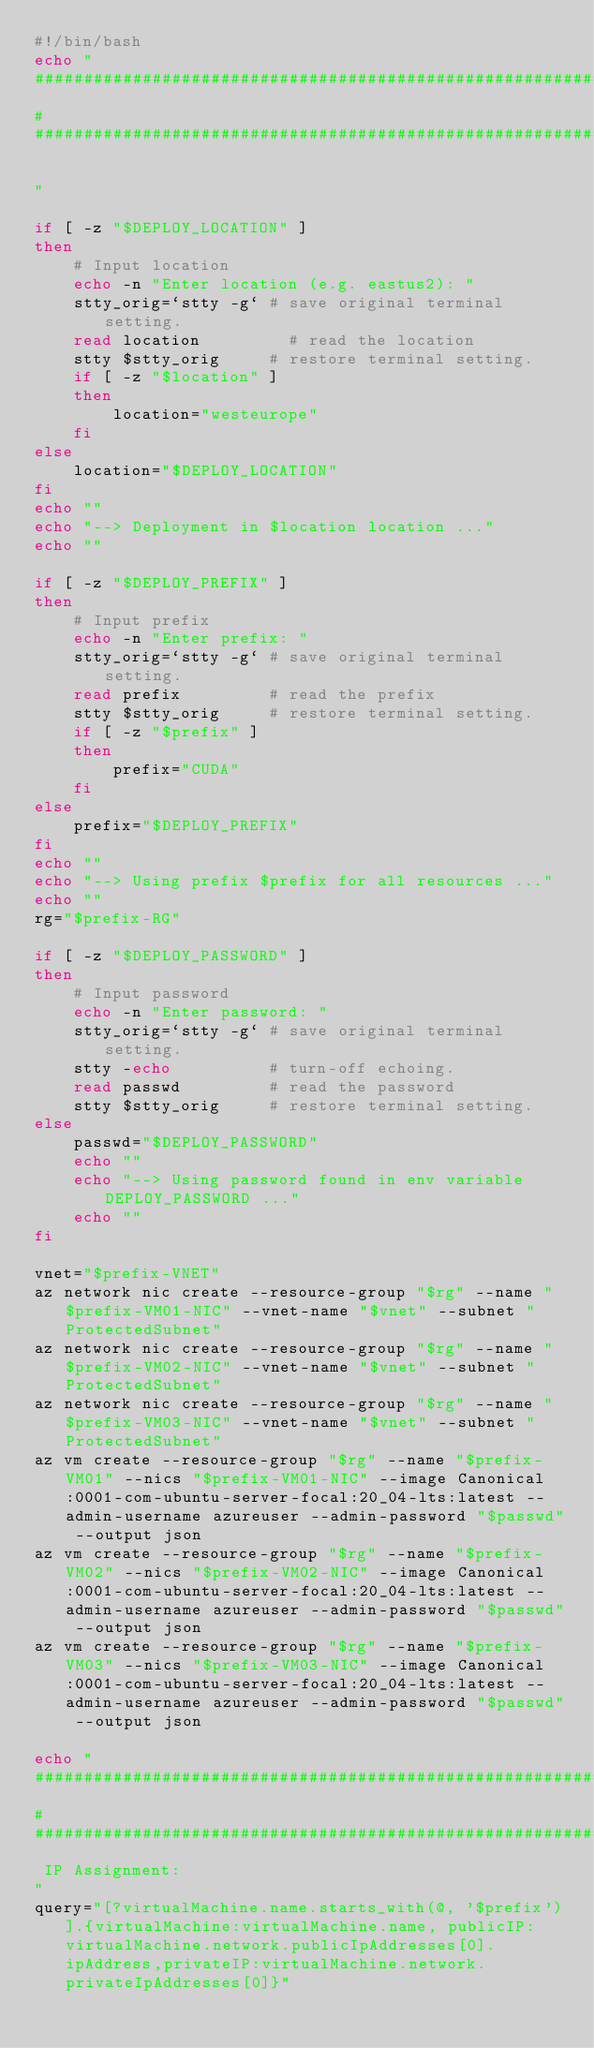<code> <loc_0><loc_0><loc_500><loc_500><_Bash_>#!/bin/bash
echo "
##############################################################################################################
#
##############################################################################################################

"

if [ -z "$DEPLOY_LOCATION" ]
then
    # Input location
    echo -n "Enter location (e.g. eastus2): "
    stty_orig=`stty -g` # save original terminal setting.
    read location         # read the location
    stty $stty_orig     # restore terminal setting.
    if [ -z "$location" ]
    then
        location="westeurope"
    fi
else
    location="$DEPLOY_LOCATION"
fi
echo ""
echo "--> Deployment in $location location ..."
echo ""

if [ -z "$DEPLOY_PREFIX" ]
then
    # Input prefix
    echo -n "Enter prefix: "
    stty_orig=`stty -g` # save original terminal setting.
    read prefix         # read the prefix
    stty $stty_orig     # restore terminal setting.
    if [ -z "$prefix" ]
    then
        prefix="CUDA"
    fi
else
    prefix="$DEPLOY_PREFIX"
fi
echo ""
echo "--> Using prefix $prefix for all resources ..."
echo ""
rg="$prefix-RG"

if [ -z "$DEPLOY_PASSWORD" ]
then
    # Input password
    echo -n "Enter password: "
    stty_orig=`stty -g` # save original terminal setting.
    stty -echo          # turn-off echoing.
    read passwd         # read the password
    stty $stty_orig     # restore terminal setting.
else
    passwd="$DEPLOY_PASSWORD"
    echo ""
    echo "--> Using password found in env variable DEPLOY_PASSWORD ..."
    echo ""
fi

vnet="$prefix-VNET"
az network nic create --resource-group "$rg" --name "$prefix-VM01-NIC" --vnet-name "$vnet" --subnet "ProtectedSubnet"
az network nic create --resource-group "$rg" --name "$prefix-VM02-NIC" --vnet-name "$vnet" --subnet "ProtectedSubnet"
az network nic create --resource-group "$rg" --name "$prefix-VM03-NIC" --vnet-name "$vnet" --subnet "ProtectedSubnet"
az vm create --resource-group "$rg" --name "$prefix-VM01" --nics "$prefix-VM01-NIC" --image Canonical:0001-com-ubuntu-server-focal:20_04-lts:latest --admin-username azureuser --admin-password "$passwd" --output json
az vm create --resource-group "$rg" --name "$prefix-VM02" --nics "$prefix-VM02-NIC" --image Canonical:0001-com-ubuntu-server-focal:20_04-lts:latest --admin-username azureuser --admin-password "$passwd" --output json
az vm create --resource-group "$rg" --name "$prefix-VM03" --nics "$prefix-VM03-NIC" --image Canonical:0001-com-ubuntu-server-focal:20_04-lts:latest --admin-username azureuser --admin-password "$passwd" --output json

echo "
##############################################################################################################
#
##############################################################################################################
 IP Assignment:
"
query="[?virtualMachine.name.starts_with(@, '$prefix')].{virtualMachine:virtualMachine.name, publicIP:virtualMachine.network.publicIpAddresses[0].ipAddress,privateIP:virtualMachine.network.privateIpAddresses[0]}"</code> 